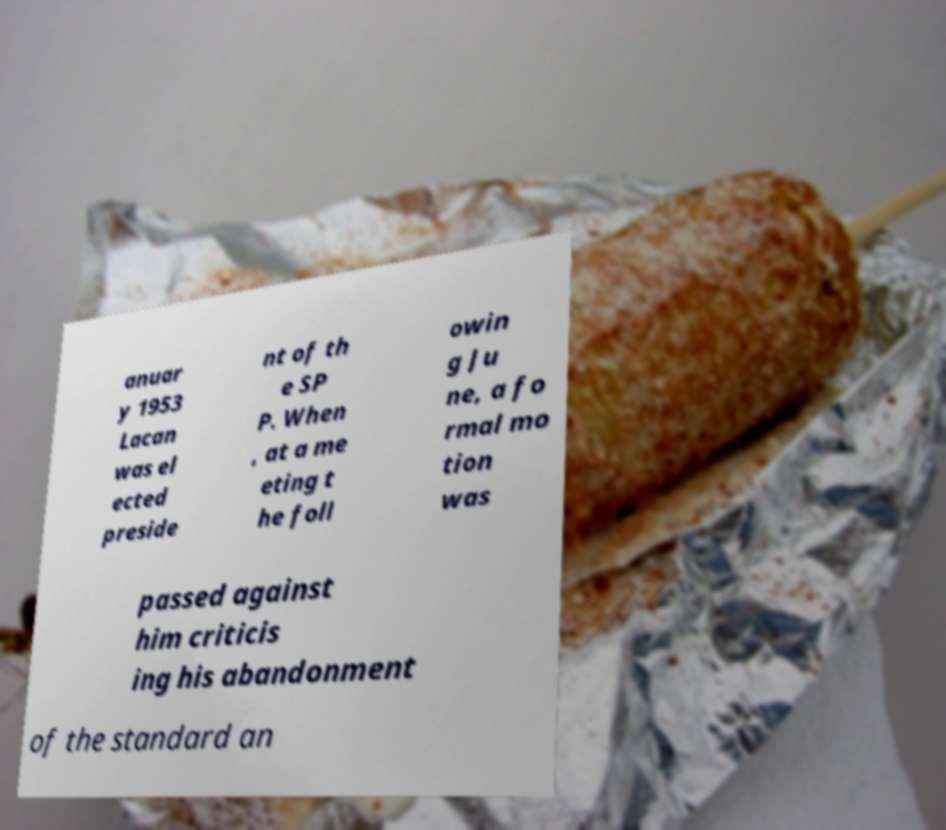I need the written content from this picture converted into text. Can you do that? anuar y 1953 Lacan was el ected preside nt of th e SP P. When , at a me eting t he foll owin g Ju ne, a fo rmal mo tion was passed against him criticis ing his abandonment of the standard an 